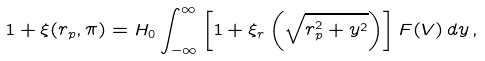Convert formula to latex. <formula><loc_0><loc_0><loc_500><loc_500>1 + \xi ( r _ { p } , \pi ) = H _ { 0 } \int _ { - \infty } ^ { \infty } \left [ 1 + \xi _ { r } \left ( \sqrt { r _ { p } ^ { 2 } + y ^ { 2 } } \right ) \right ] F ( V ) \, d y \, ,</formula> 